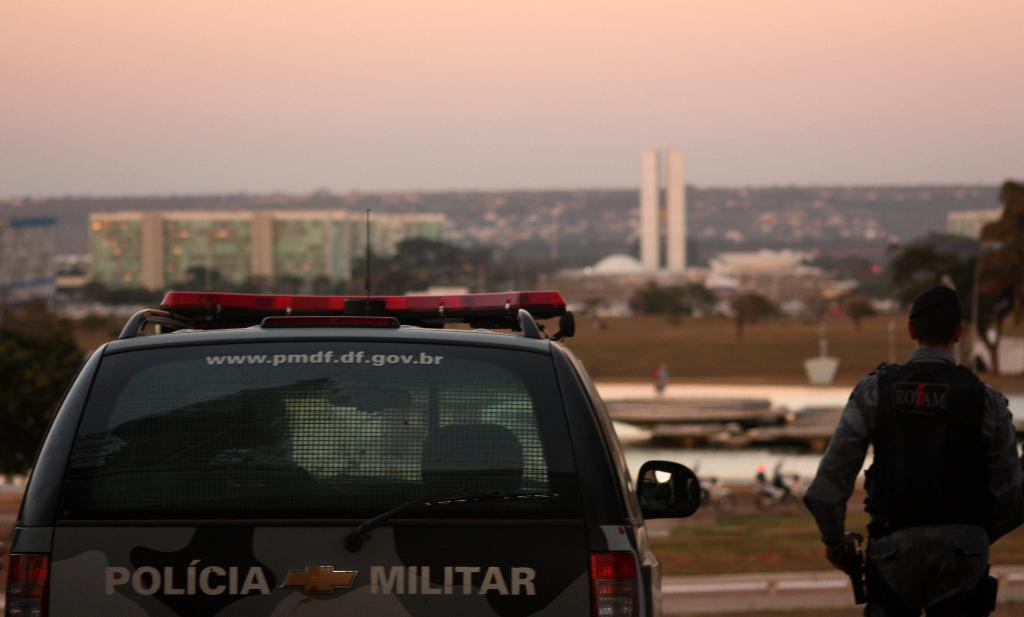What can be seen on the left side of the image? There is a vehicle on the left side of the image. What is happening on the right side of the image? There is a man standing on the right side of the image. What can be seen in the background of the image? There are buildings, trees, and the sky visible in the background of the image. What type of pig is being used to fill the pail in the image? There is no pig or pail present in the image. How does the man express his feelings of hate towards the buildings in the image? The image does not show any expressions of hate or any indication that the man has negative feelings towards the buildings. 